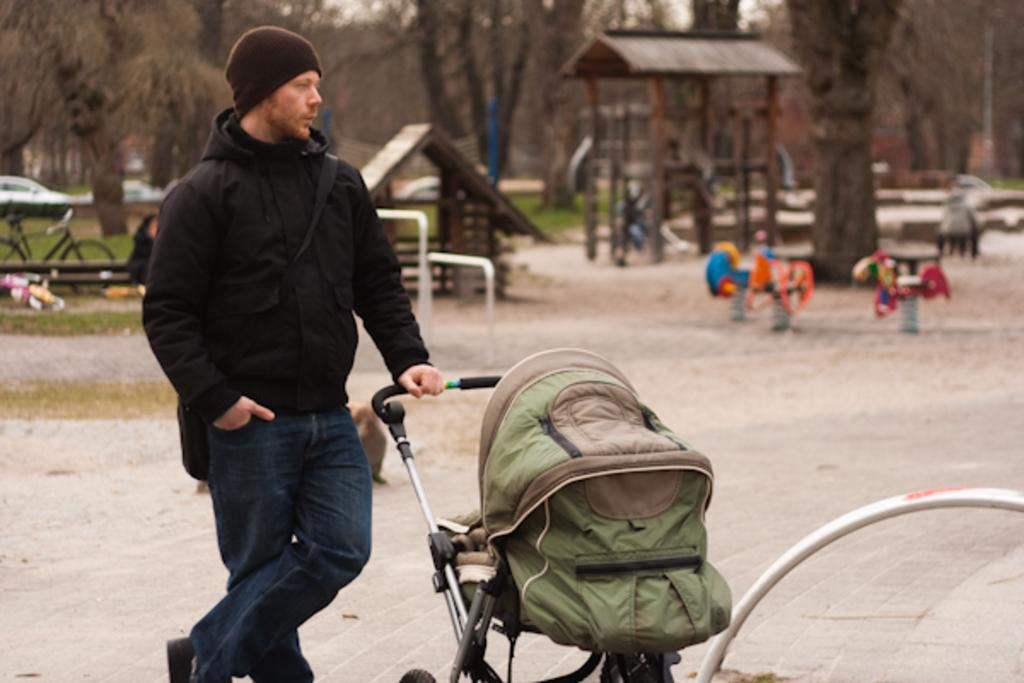What is the person in the image holding? The person is holding a stroller in the image. What is the position of the person in the image? The person is standing in the image. Can you describe the background of the image? The background of the image has a blurred view, with people, wooden objects, vehicles, grass, and trees visible. What type of camera is the person using to take a picture of their hands in the image? There is no camera or hands visible in the image, and therefore no such activity can be observed. 